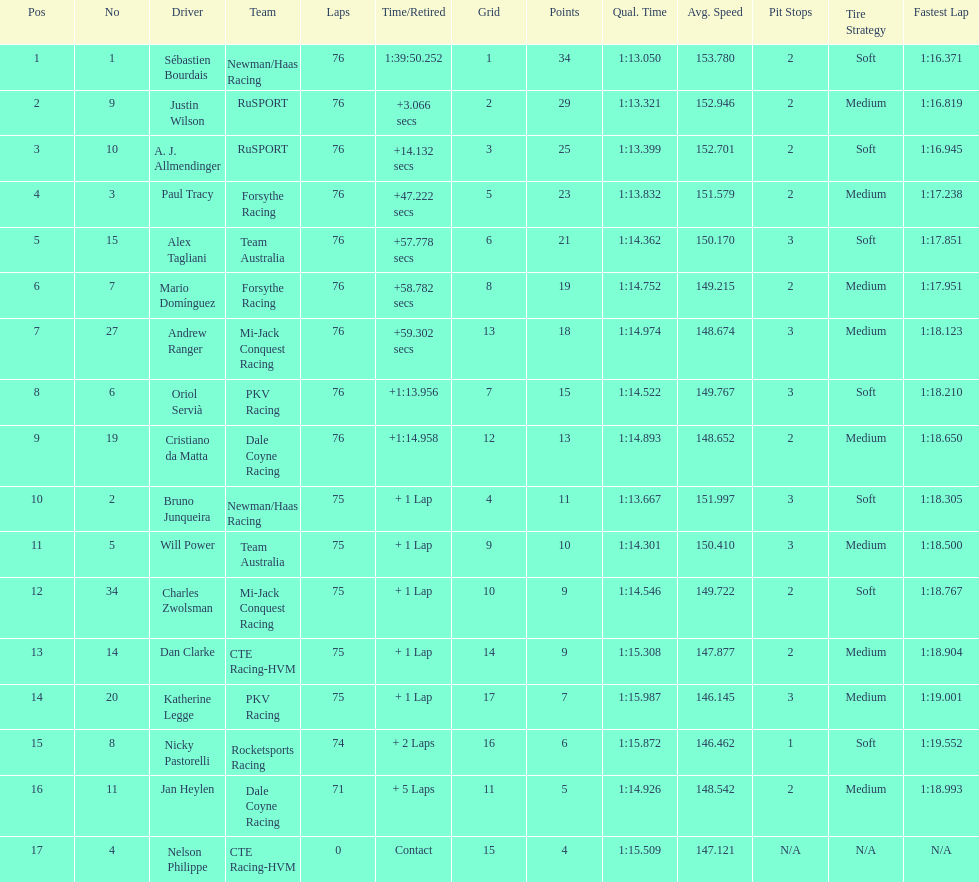What drivers took part in the 2006 tecate grand prix of monterrey? Sébastien Bourdais, Justin Wilson, A. J. Allmendinger, Paul Tracy, Alex Tagliani, Mario Domínguez, Andrew Ranger, Oriol Servià, Cristiano da Matta, Bruno Junqueira, Will Power, Charles Zwolsman, Dan Clarke, Katherine Legge, Nicky Pastorelli, Jan Heylen, Nelson Philippe. Which of those drivers scored the same amount of points as another driver? Charles Zwolsman, Dan Clarke. Who had the same amount of points as charles zwolsman? Dan Clarke. 